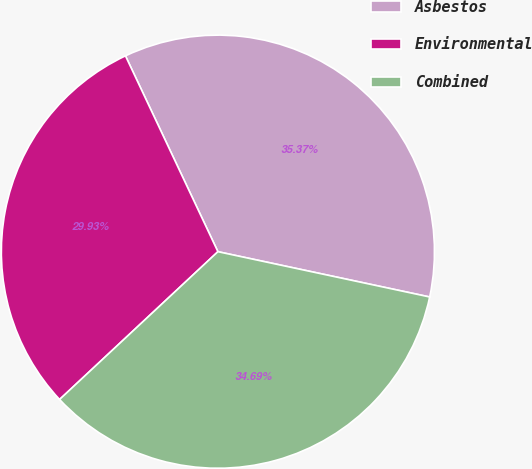<chart> <loc_0><loc_0><loc_500><loc_500><pie_chart><fcel>Asbestos<fcel>Environmental<fcel>Combined<nl><fcel>35.37%<fcel>29.93%<fcel>34.69%<nl></chart> 